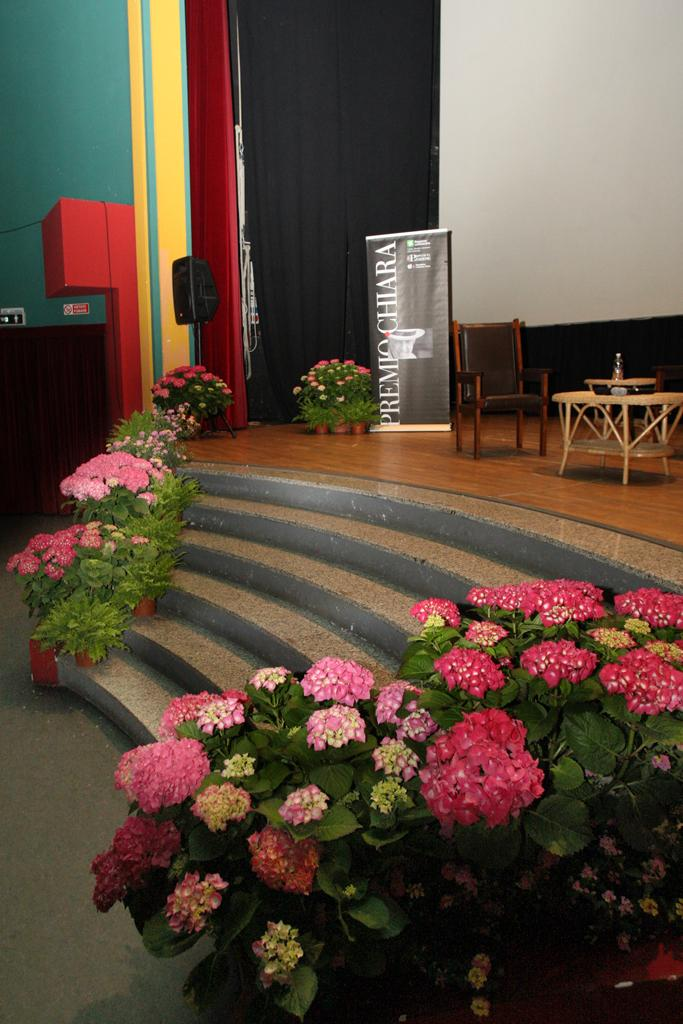What type of objects can be seen in the image? There are flower pots, colorful flowers, stairs, banners, chairs, a table, a screen, black color curtains, and other objects in the image. Can you describe the flowers in the image? The flowers in the image are colorful. What type of architectural feature is present in the image? There are stairs in the image. What might be used for displaying information or advertising in the image? Banners are present in the image for displaying information or advertising. What type of furniture is visible in the image? Chairs are visible in the image. What type of surface is present in the image for placing objects? There is a table in the image for placing objects. What type of barrier is present in the image? Black color curtains are in the image, which can act as a barrier. What type of background can be seen in the image? There is a wall in the image. What type of reward is being given to the army representative in the image? There is no army representative or reward present in the image. 